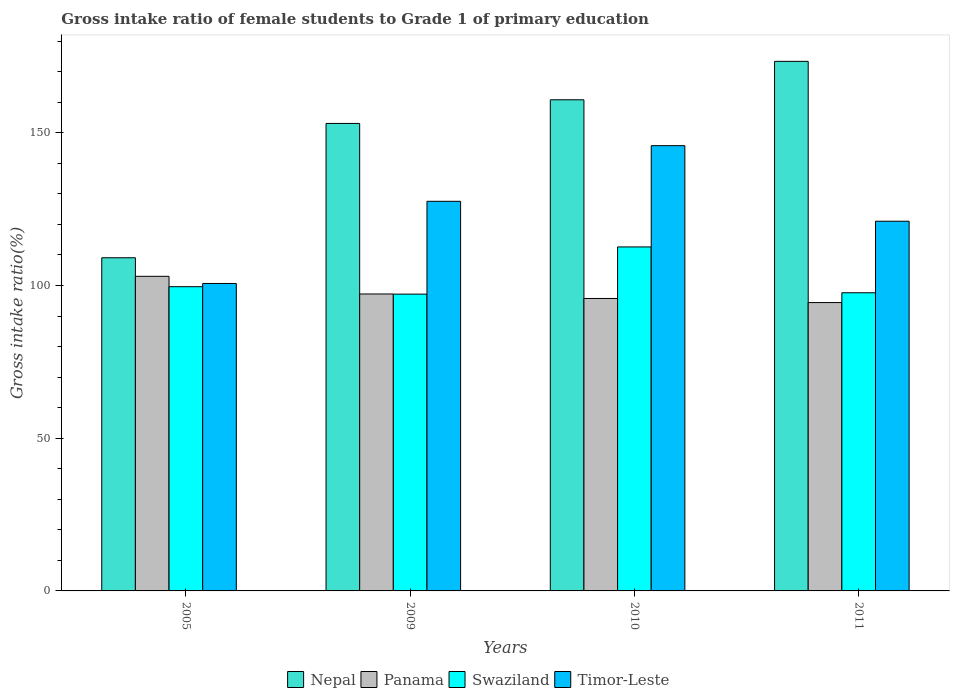How many bars are there on the 4th tick from the left?
Your response must be concise. 4. What is the gross intake ratio in Swaziland in 2010?
Make the answer very short. 112.63. Across all years, what is the maximum gross intake ratio in Nepal?
Make the answer very short. 173.4. Across all years, what is the minimum gross intake ratio in Panama?
Offer a very short reply. 94.41. What is the total gross intake ratio in Nepal in the graph?
Ensure brevity in your answer.  596.37. What is the difference between the gross intake ratio in Panama in 2009 and that in 2010?
Your answer should be compact. 1.47. What is the difference between the gross intake ratio in Nepal in 2010 and the gross intake ratio in Timor-Leste in 2009?
Give a very brief answer. 33.24. What is the average gross intake ratio in Timor-Leste per year?
Your answer should be very brief. 123.77. In the year 2005, what is the difference between the gross intake ratio in Nepal and gross intake ratio in Panama?
Keep it short and to the point. 6.08. In how many years, is the gross intake ratio in Panama greater than 30 %?
Make the answer very short. 4. What is the ratio of the gross intake ratio in Nepal in 2005 to that in 2011?
Your answer should be compact. 0.63. Is the difference between the gross intake ratio in Nepal in 2005 and 2011 greater than the difference between the gross intake ratio in Panama in 2005 and 2011?
Your answer should be very brief. No. What is the difference between the highest and the second highest gross intake ratio in Nepal?
Keep it short and to the point. 12.59. What is the difference between the highest and the lowest gross intake ratio in Nepal?
Ensure brevity in your answer.  64.31. In how many years, is the gross intake ratio in Timor-Leste greater than the average gross intake ratio in Timor-Leste taken over all years?
Keep it short and to the point. 2. What does the 3rd bar from the left in 2011 represents?
Your answer should be compact. Swaziland. What does the 1st bar from the right in 2005 represents?
Provide a short and direct response. Timor-Leste. How many bars are there?
Offer a very short reply. 16. How many years are there in the graph?
Keep it short and to the point. 4. What is the difference between two consecutive major ticks on the Y-axis?
Your response must be concise. 50. Are the values on the major ticks of Y-axis written in scientific E-notation?
Ensure brevity in your answer.  No. How are the legend labels stacked?
Keep it short and to the point. Horizontal. What is the title of the graph?
Offer a very short reply. Gross intake ratio of female students to Grade 1 of primary education. What is the label or title of the Y-axis?
Your response must be concise. Gross intake ratio(%). What is the Gross intake ratio(%) of Nepal in 2005?
Offer a terse response. 109.09. What is the Gross intake ratio(%) in Panama in 2005?
Your response must be concise. 103.01. What is the Gross intake ratio(%) in Swaziland in 2005?
Provide a succinct answer. 99.61. What is the Gross intake ratio(%) of Timor-Leste in 2005?
Your answer should be very brief. 100.67. What is the Gross intake ratio(%) in Nepal in 2009?
Offer a terse response. 153.07. What is the Gross intake ratio(%) of Panama in 2009?
Offer a very short reply. 97.23. What is the Gross intake ratio(%) in Swaziland in 2009?
Your response must be concise. 97.18. What is the Gross intake ratio(%) of Timor-Leste in 2009?
Your answer should be very brief. 127.57. What is the Gross intake ratio(%) of Nepal in 2010?
Offer a terse response. 160.81. What is the Gross intake ratio(%) of Panama in 2010?
Ensure brevity in your answer.  95.75. What is the Gross intake ratio(%) in Swaziland in 2010?
Provide a succinct answer. 112.63. What is the Gross intake ratio(%) in Timor-Leste in 2010?
Ensure brevity in your answer.  145.79. What is the Gross intake ratio(%) of Nepal in 2011?
Your response must be concise. 173.4. What is the Gross intake ratio(%) of Panama in 2011?
Offer a terse response. 94.41. What is the Gross intake ratio(%) of Swaziland in 2011?
Provide a succinct answer. 97.63. What is the Gross intake ratio(%) in Timor-Leste in 2011?
Provide a succinct answer. 121.05. Across all years, what is the maximum Gross intake ratio(%) in Nepal?
Ensure brevity in your answer.  173.4. Across all years, what is the maximum Gross intake ratio(%) in Panama?
Offer a very short reply. 103.01. Across all years, what is the maximum Gross intake ratio(%) of Swaziland?
Provide a short and direct response. 112.63. Across all years, what is the maximum Gross intake ratio(%) of Timor-Leste?
Your answer should be compact. 145.79. Across all years, what is the minimum Gross intake ratio(%) in Nepal?
Your answer should be compact. 109.09. Across all years, what is the minimum Gross intake ratio(%) in Panama?
Ensure brevity in your answer.  94.41. Across all years, what is the minimum Gross intake ratio(%) of Swaziland?
Ensure brevity in your answer.  97.18. Across all years, what is the minimum Gross intake ratio(%) of Timor-Leste?
Offer a very short reply. 100.67. What is the total Gross intake ratio(%) in Nepal in the graph?
Give a very brief answer. 596.37. What is the total Gross intake ratio(%) in Panama in the graph?
Provide a succinct answer. 390.4. What is the total Gross intake ratio(%) of Swaziland in the graph?
Ensure brevity in your answer.  407.05. What is the total Gross intake ratio(%) in Timor-Leste in the graph?
Provide a succinct answer. 495.08. What is the difference between the Gross intake ratio(%) in Nepal in 2005 and that in 2009?
Your answer should be compact. -43.98. What is the difference between the Gross intake ratio(%) in Panama in 2005 and that in 2009?
Your answer should be very brief. 5.78. What is the difference between the Gross intake ratio(%) of Swaziland in 2005 and that in 2009?
Keep it short and to the point. 2.43. What is the difference between the Gross intake ratio(%) in Timor-Leste in 2005 and that in 2009?
Ensure brevity in your answer.  -26.91. What is the difference between the Gross intake ratio(%) in Nepal in 2005 and that in 2010?
Offer a terse response. -51.72. What is the difference between the Gross intake ratio(%) in Panama in 2005 and that in 2010?
Make the answer very short. 7.25. What is the difference between the Gross intake ratio(%) in Swaziland in 2005 and that in 2010?
Provide a short and direct response. -13.02. What is the difference between the Gross intake ratio(%) of Timor-Leste in 2005 and that in 2010?
Provide a succinct answer. -45.12. What is the difference between the Gross intake ratio(%) in Nepal in 2005 and that in 2011?
Your response must be concise. -64.31. What is the difference between the Gross intake ratio(%) in Panama in 2005 and that in 2011?
Give a very brief answer. 8.6. What is the difference between the Gross intake ratio(%) in Swaziland in 2005 and that in 2011?
Give a very brief answer. 1.99. What is the difference between the Gross intake ratio(%) in Timor-Leste in 2005 and that in 2011?
Ensure brevity in your answer.  -20.38. What is the difference between the Gross intake ratio(%) of Nepal in 2009 and that in 2010?
Your answer should be very brief. -7.74. What is the difference between the Gross intake ratio(%) of Panama in 2009 and that in 2010?
Ensure brevity in your answer.  1.47. What is the difference between the Gross intake ratio(%) in Swaziland in 2009 and that in 2010?
Your response must be concise. -15.45. What is the difference between the Gross intake ratio(%) in Timor-Leste in 2009 and that in 2010?
Your response must be concise. -18.22. What is the difference between the Gross intake ratio(%) in Nepal in 2009 and that in 2011?
Your response must be concise. -20.33. What is the difference between the Gross intake ratio(%) of Panama in 2009 and that in 2011?
Your answer should be very brief. 2.81. What is the difference between the Gross intake ratio(%) in Swaziland in 2009 and that in 2011?
Your answer should be very brief. -0.45. What is the difference between the Gross intake ratio(%) of Timor-Leste in 2009 and that in 2011?
Provide a succinct answer. 6.52. What is the difference between the Gross intake ratio(%) in Nepal in 2010 and that in 2011?
Your answer should be very brief. -12.59. What is the difference between the Gross intake ratio(%) of Panama in 2010 and that in 2011?
Your answer should be compact. 1.34. What is the difference between the Gross intake ratio(%) of Swaziland in 2010 and that in 2011?
Your answer should be very brief. 15.01. What is the difference between the Gross intake ratio(%) in Timor-Leste in 2010 and that in 2011?
Offer a very short reply. 24.74. What is the difference between the Gross intake ratio(%) of Nepal in 2005 and the Gross intake ratio(%) of Panama in 2009?
Offer a terse response. 11.86. What is the difference between the Gross intake ratio(%) of Nepal in 2005 and the Gross intake ratio(%) of Swaziland in 2009?
Your response must be concise. 11.91. What is the difference between the Gross intake ratio(%) of Nepal in 2005 and the Gross intake ratio(%) of Timor-Leste in 2009?
Your response must be concise. -18.49. What is the difference between the Gross intake ratio(%) in Panama in 2005 and the Gross intake ratio(%) in Swaziland in 2009?
Ensure brevity in your answer.  5.83. What is the difference between the Gross intake ratio(%) in Panama in 2005 and the Gross intake ratio(%) in Timor-Leste in 2009?
Provide a succinct answer. -24.56. What is the difference between the Gross intake ratio(%) of Swaziland in 2005 and the Gross intake ratio(%) of Timor-Leste in 2009?
Your response must be concise. -27.96. What is the difference between the Gross intake ratio(%) of Nepal in 2005 and the Gross intake ratio(%) of Panama in 2010?
Your response must be concise. 13.33. What is the difference between the Gross intake ratio(%) in Nepal in 2005 and the Gross intake ratio(%) in Swaziland in 2010?
Ensure brevity in your answer.  -3.54. What is the difference between the Gross intake ratio(%) of Nepal in 2005 and the Gross intake ratio(%) of Timor-Leste in 2010?
Your response must be concise. -36.7. What is the difference between the Gross intake ratio(%) in Panama in 2005 and the Gross intake ratio(%) in Swaziland in 2010?
Ensure brevity in your answer.  -9.62. What is the difference between the Gross intake ratio(%) of Panama in 2005 and the Gross intake ratio(%) of Timor-Leste in 2010?
Your answer should be very brief. -42.78. What is the difference between the Gross intake ratio(%) of Swaziland in 2005 and the Gross intake ratio(%) of Timor-Leste in 2010?
Ensure brevity in your answer.  -46.18. What is the difference between the Gross intake ratio(%) of Nepal in 2005 and the Gross intake ratio(%) of Panama in 2011?
Make the answer very short. 14.68. What is the difference between the Gross intake ratio(%) of Nepal in 2005 and the Gross intake ratio(%) of Swaziland in 2011?
Your answer should be very brief. 11.46. What is the difference between the Gross intake ratio(%) in Nepal in 2005 and the Gross intake ratio(%) in Timor-Leste in 2011?
Your response must be concise. -11.96. What is the difference between the Gross intake ratio(%) in Panama in 2005 and the Gross intake ratio(%) in Swaziland in 2011?
Make the answer very short. 5.38. What is the difference between the Gross intake ratio(%) of Panama in 2005 and the Gross intake ratio(%) of Timor-Leste in 2011?
Keep it short and to the point. -18.04. What is the difference between the Gross intake ratio(%) of Swaziland in 2005 and the Gross intake ratio(%) of Timor-Leste in 2011?
Make the answer very short. -21.44. What is the difference between the Gross intake ratio(%) of Nepal in 2009 and the Gross intake ratio(%) of Panama in 2010?
Make the answer very short. 57.32. What is the difference between the Gross intake ratio(%) in Nepal in 2009 and the Gross intake ratio(%) in Swaziland in 2010?
Offer a terse response. 40.44. What is the difference between the Gross intake ratio(%) in Nepal in 2009 and the Gross intake ratio(%) in Timor-Leste in 2010?
Keep it short and to the point. 7.28. What is the difference between the Gross intake ratio(%) in Panama in 2009 and the Gross intake ratio(%) in Swaziland in 2010?
Provide a short and direct response. -15.41. What is the difference between the Gross intake ratio(%) in Panama in 2009 and the Gross intake ratio(%) in Timor-Leste in 2010?
Your answer should be very brief. -48.56. What is the difference between the Gross intake ratio(%) in Swaziland in 2009 and the Gross intake ratio(%) in Timor-Leste in 2010?
Your answer should be very brief. -48.61. What is the difference between the Gross intake ratio(%) of Nepal in 2009 and the Gross intake ratio(%) of Panama in 2011?
Offer a terse response. 58.66. What is the difference between the Gross intake ratio(%) of Nepal in 2009 and the Gross intake ratio(%) of Swaziland in 2011?
Your answer should be very brief. 55.45. What is the difference between the Gross intake ratio(%) in Nepal in 2009 and the Gross intake ratio(%) in Timor-Leste in 2011?
Offer a terse response. 32.02. What is the difference between the Gross intake ratio(%) of Panama in 2009 and the Gross intake ratio(%) of Swaziland in 2011?
Make the answer very short. -0.4. What is the difference between the Gross intake ratio(%) of Panama in 2009 and the Gross intake ratio(%) of Timor-Leste in 2011?
Make the answer very short. -23.82. What is the difference between the Gross intake ratio(%) of Swaziland in 2009 and the Gross intake ratio(%) of Timor-Leste in 2011?
Offer a terse response. -23.87. What is the difference between the Gross intake ratio(%) in Nepal in 2010 and the Gross intake ratio(%) in Panama in 2011?
Provide a short and direct response. 66.4. What is the difference between the Gross intake ratio(%) of Nepal in 2010 and the Gross intake ratio(%) of Swaziland in 2011?
Your answer should be very brief. 63.19. What is the difference between the Gross intake ratio(%) in Nepal in 2010 and the Gross intake ratio(%) in Timor-Leste in 2011?
Make the answer very short. 39.76. What is the difference between the Gross intake ratio(%) of Panama in 2010 and the Gross intake ratio(%) of Swaziland in 2011?
Ensure brevity in your answer.  -1.87. What is the difference between the Gross intake ratio(%) in Panama in 2010 and the Gross intake ratio(%) in Timor-Leste in 2011?
Offer a very short reply. -25.3. What is the difference between the Gross intake ratio(%) in Swaziland in 2010 and the Gross intake ratio(%) in Timor-Leste in 2011?
Keep it short and to the point. -8.42. What is the average Gross intake ratio(%) in Nepal per year?
Your response must be concise. 149.09. What is the average Gross intake ratio(%) of Panama per year?
Make the answer very short. 97.6. What is the average Gross intake ratio(%) of Swaziland per year?
Ensure brevity in your answer.  101.76. What is the average Gross intake ratio(%) of Timor-Leste per year?
Offer a very short reply. 123.77. In the year 2005, what is the difference between the Gross intake ratio(%) of Nepal and Gross intake ratio(%) of Panama?
Provide a short and direct response. 6.08. In the year 2005, what is the difference between the Gross intake ratio(%) in Nepal and Gross intake ratio(%) in Swaziland?
Give a very brief answer. 9.48. In the year 2005, what is the difference between the Gross intake ratio(%) in Nepal and Gross intake ratio(%) in Timor-Leste?
Keep it short and to the point. 8.42. In the year 2005, what is the difference between the Gross intake ratio(%) in Panama and Gross intake ratio(%) in Swaziland?
Make the answer very short. 3.4. In the year 2005, what is the difference between the Gross intake ratio(%) of Panama and Gross intake ratio(%) of Timor-Leste?
Ensure brevity in your answer.  2.34. In the year 2005, what is the difference between the Gross intake ratio(%) of Swaziland and Gross intake ratio(%) of Timor-Leste?
Provide a succinct answer. -1.06. In the year 2009, what is the difference between the Gross intake ratio(%) in Nepal and Gross intake ratio(%) in Panama?
Your answer should be compact. 55.84. In the year 2009, what is the difference between the Gross intake ratio(%) in Nepal and Gross intake ratio(%) in Swaziland?
Provide a succinct answer. 55.89. In the year 2009, what is the difference between the Gross intake ratio(%) in Nepal and Gross intake ratio(%) in Timor-Leste?
Keep it short and to the point. 25.5. In the year 2009, what is the difference between the Gross intake ratio(%) of Panama and Gross intake ratio(%) of Swaziland?
Provide a succinct answer. 0.05. In the year 2009, what is the difference between the Gross intake ratio(%) in Panama and Gross intake ratio(%) in Timor-Leste?
Your response must be concise. -30.35. In the year 2009, what is the difference between the Gross intake ratio(%) of Swaziland and Gross intake ratio(%) of Timor-Leste?
Your response must be concise. -30.4. In the year 2010, what is the difference between the Gross intake ratio(%) in Nepal and Gross intake ratio(%) in Panama?
Ensure brevity in your answer.  65.06. In the year 2010, what is the difference between the Gross intake ratio(%) of Nepal and Gross intake ratio(%) of Swaziland?
Your answer should be very brief. 48.18. In the year 2010, what is the difference between the Gross intake ratio(%) of Nepal and Gross intake ratio(%) of Timor-Leste?
Provide a succinct answer. 15.02. In the year 2010, what is the difference between the Gross intake ratio(%) of Panama and Gross intake ratio(%) of Swaziland?
Keep it short and to the point. -16.88. In the year 2010, what is the difference between the Gross intake ratio(%) of Panama and Gross intake ratio(%) of Timor-Leste?
Your response must be concise. -50.04. In the year 2010, what is the difference between the Gross intake ratio(%) in Swaziland and Gross intake ratio(%) in Timor-Leste?
Keep it short and to the point. -33.16. In the year 2011, what is the difference between the Gross intake ratio(%) in Nepal and Gross intake ratio(%) in Panama?
Offer a very short reply. 78.98. In the year 2011, what is the difference between the Gross intake ratio(%) of Nepal and Gross intake ratio(%) of Swaziland?
Ensure brevity in your answer.  75.77. In the year 2011, what is the difference between the Gross intake ratio(%) of Nepal and Gross intake ratio(%) of Timor-Leste?
Ensure brevity in your answer.  52.35. In the year 2011, what is the difference between the Gross intake ratio(%) of Panama and Gross intake ratio(%) of Swaziland?
Offer a terse response. -3.21. In the year 2011, what is the difference between the Gross intake ratio(%) of Panama and Gross intake ratio(%) of Timor-Leste?
Give a very brief answer. -26.64. In the year 2011, what is the difference between the Gross intake ratio(%) in Swaziland and Gross intake ratio(%) in Timor-Leste?
Give a very brief answer. -23.43. What is the ratio of the Gross intake ratio(%) of Nepal in 2005 to that in 2009?
Provide a succinct answer. 0.71. What is the ratio of the Gross intake ratio(%) in Panama in 2005 to that in 2009?
Give a very brief answer. 1.06. What is the ratio of the Gross intake ratio(%) in Timor-Leste in 2005 to that in 2009?
Offer a very short reply. 0.79. What is the ratio of the Gross intake ratio(%) of Nepal in 2005 to that in 2010?
Make the answer very short. 0.68. What is the ratio of the Gross intake ratio(%) in Panama in 2005 to that in 2010?
Your response must be concise. 1.08. What is the ratio of the Gross intake ratio(%) in Swaziland in 2005 to that in 2010?
Offer a terse response. 0.88. What is the ratio of the Gross intake ratio(%) in Timor-Leste in 2005 to that in 2010?
Your answer should be very brief. 0.69. What is the ratio of the Gross intake ratio(%) of Nepal in 2005 to that in 2011?
Make the answer very short. 0.63. What is the ratio of the Gross intake ratio(%) of Panama in 2005 to that in 2011?
Ensure brevity in your answer.  1.09. What is the ratio of the Gross intake ratio(%) of Swaziland in 2005 to that in 2011?
Offer a very short reply. 1.02. What is the ratio of the Gross intake ratio(%) of Timor-Leste in 2005 to that in 2011?
Provide a short and direct response. 0.83. What is the ratio of the Gross intake ratio(%) in Nepal in 2009 to that in 2010?
Offer a terse response. 0.95. What is the ratio of the Gross intake ratio(%) in Panama in 2009 to that in 2010?
Your response must be concise. 1.02. What is the ratio of the Gross intake ratio(%) in Swaziland in 2009 to that in 2010?
Provide a succinct answer. 0.86. What is the ratio of the Gross intake ratio(%) in Timor-Leste in 2009 to that in 2010?
Give a very brief answer. 0.88. What is the ratio of the Gross intake ratio(%) of Nepal in 2009 to that in 2011?
Your answer should be compact. 0.88. What is the ratio of the Gross intake ratio(%) in Panama in 2009 to that in 2011?
Offer a very short reply. 1.03. What is the ratio of the Gross intake ratio(%) in Swaziland in 2009 to that in 2011?
Offer a terse response. 1. What is the ratio of the Gross intake ratio(%) of Timor-Leste in 2009 to that in 2011?
Provide a succinct answer. 1.05. What is the ratio of the Gross intake ratio(%) in Nepal in 2010 to that in 2011?
Ensure brevity in your answer.  0.93. What is the ratio of the Gross intake ratio(%) in Panama in 2010 to that in 2011?
Make the answer very short. 1.01. What is the ratio of the Gross intake ratio(%) of Swaziland in 2010 to that in 2011?
Ensure brevity in your answer.  1.15. What is the ratio of the Gross intake ratio(%) in Timor-Leste in 2010 to that in 2011?
Your answer should be compact. 1.2. What is the difference between the highest and the second highest Gross intake ratio(%) in Nepal?
Offer a terse response. 12.59. What is the difference between the highest and the second highest Gross intake ratio(%) of Panama?
Provide a short and direct response. 5.78. What is the difference between the highest and the second highest Gross intake ratio(%) in Swaziland?
Your response must be concise. 13.02. What is the difference between the highest and the second highest Gross intake ratio(%) in Timor-Leste?
Ensure brevity in your answer.  18.22. What is the difference between the highest and the lowest Gross intake ratio(%) of Nepal?
Keep it short and to the point. 64.31. What is the difference between the highest and the lowest Gross intake ratio(%) of Panama?
Give a very brief answer. 8.6. What is the difference between the highest and the lowest Gross intake ratio(%) in Swaziland?
Your answer should be compact. 15.45. What is the difference between the highest and the lowest Gross intake ratio(%) of Timor-Leste?
Give a very brief answer. 45.12. 